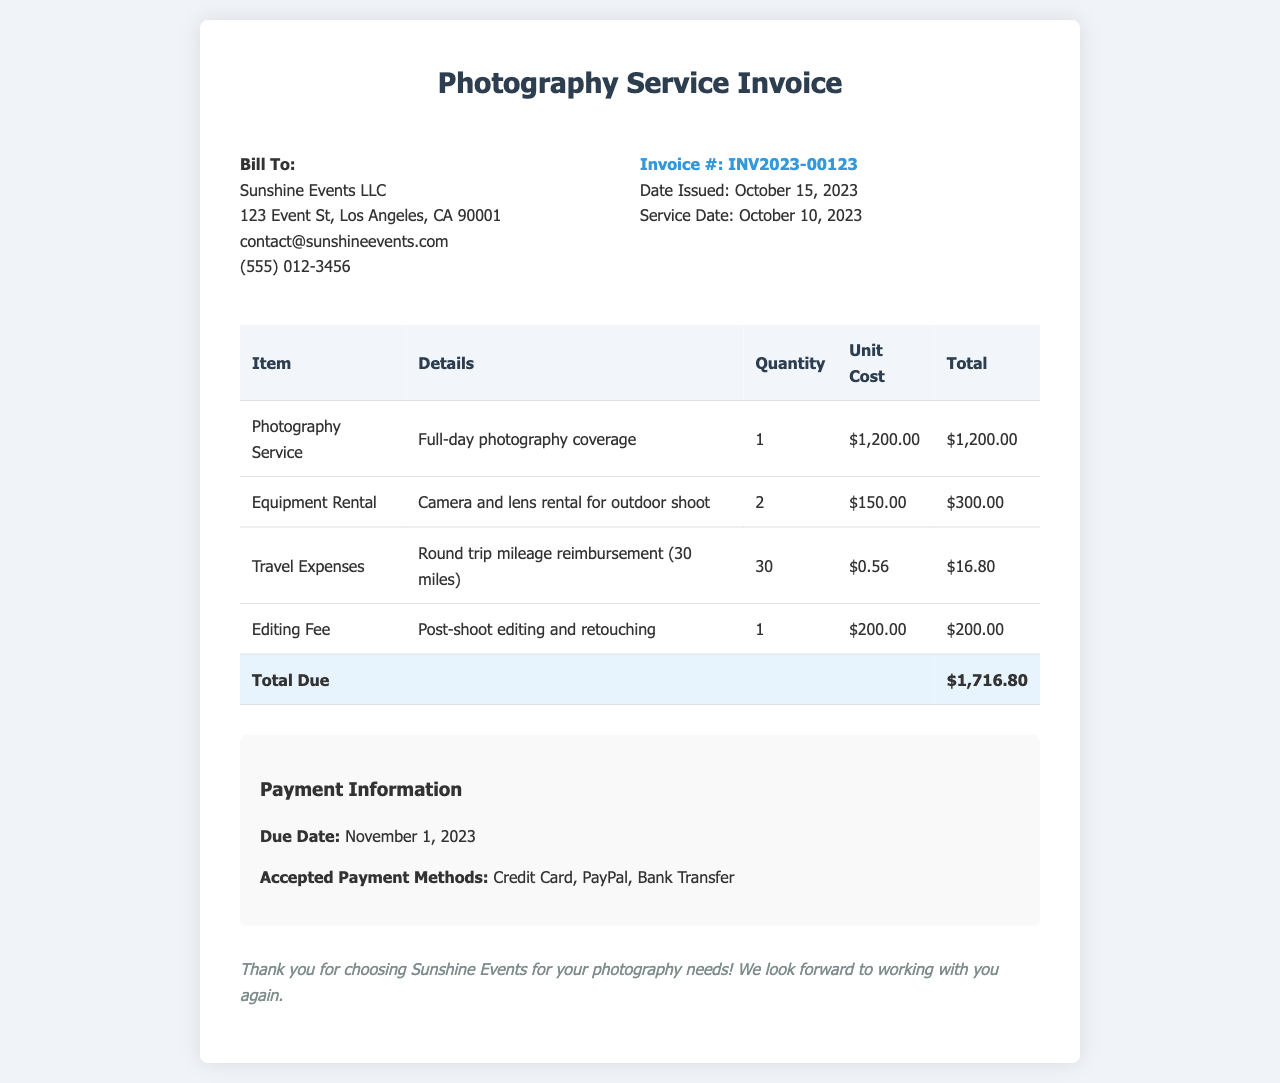What is the invoice number? The invoice number can be found in the invoice details section, which is labeled as "Invoice #".
Answer: INV2023-00123 Who is the bill to? The "Bill To" section includes the name of the organization receiving the invoice, which is located at the beginning of the document.
Answer: Sunshine Events LLC What is the total due? The total due is shown at the bottom of the table, under the row labeled "Total Due".
Answer: $1,716.80 When is the due date for payment? The due date is specified in the payment information section of the document.
Answer: November 1, 2023 How much was charged for the photography service? The price for photography service is listed in the "Item" column of the table, which details individual costs.
Answer: $1,200.00 How many miles were reimbursed for travel expenses? The travel expenses section indicates the total miles eligible for reimbursement as detailed in the description.
Answer: 30 What equipment was rented? The equipment rental section specifies what was rented for the shoot in the details column.
Answer: Camera and lens What is the editing fee? The editing fee is specified in the table under the "Item" column for post-shoot editing and retouching services.
Answer: $200.00 What payment methods are accepted? The accepted payment methods are listed in the payment information section of the document.
Answer: Credit Card, PayPal, Bank Transfer 